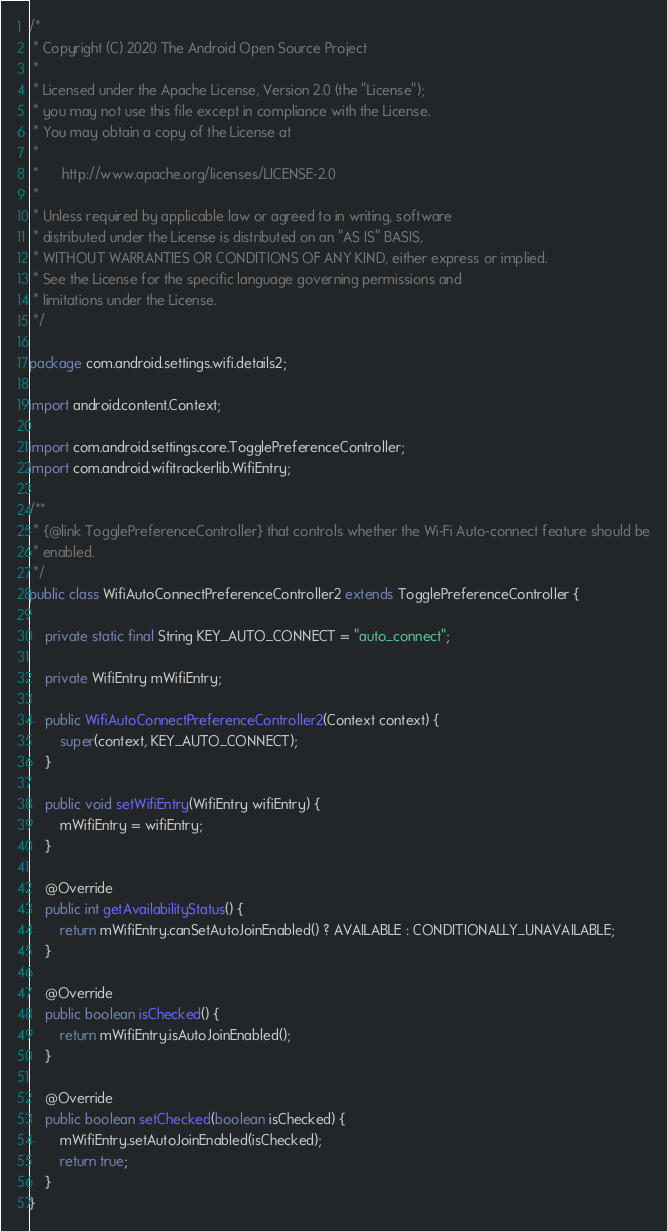<code> <loc_0><loc_0><loc_500><loc_500><_Java_>/*
 * Copyright (C) 2020 The Android Open Source Project
 *
 * Licensed under the Apache License, Version 2.0 (the "License");
 * you may not use this file except in compliance with the License.
 * You may obtain a copy of the License at
 *
 *      http://www.apache.org/licenses/LICENSE-2.0
 *
 * Unless required by applicable law or agreed to in writing, software
 * distributed under the License is distributed on an "AS IS" BASIS,
 * WITHOUT WARRANTIES OR CONDITIONS OF ANY KIND, either express or implied.
 * See the License for the specific language governing permissions and
 * limitations under the License.
 */

package com.android.settings.wifi.details2;

import android.content.Context;

import com.android.settings.core.TogglePreferenceController;
import com.android.wifitrackerlib.WifiEntry;

/**
 * {@link TogglePreferenceController} that controls whether the Wi-Fi Auto-connect feature should be
 * enabled.
 */
public class WifiAutoConnectPreferenceController2 extends TogglePreferenceController {

    private static final String KEY_AUTO_CONNECT = "auto_connect";

    private WifiEntry mWifiEntry;

    public WifiAutoConnectPreferenceController2(Context context) {
        super(context, KEY_AUTO_CONNECT);
    }

    public void setWifiEntry(WifiEntry wifiEntry) {
        mWifiEntry = wifiEntry;
    }

    @Override
    public int getAvailabilityStatus() {
        return mWifiEntry.canSetAutoJoinEnabled() ? AVAILABLE : CONDITIONALLY_UNAVAILABLE;
    }

    @Override
    public boolean isChecked() {
        return mWifiEntry.isAutoJoinEnabled();
    }

    @Override
    public boolean setChecked(boolean isChecked) {
        mWifiEntry.setAutoJoinEnabled(isChecked);
        return true;
    }
}
</code> 